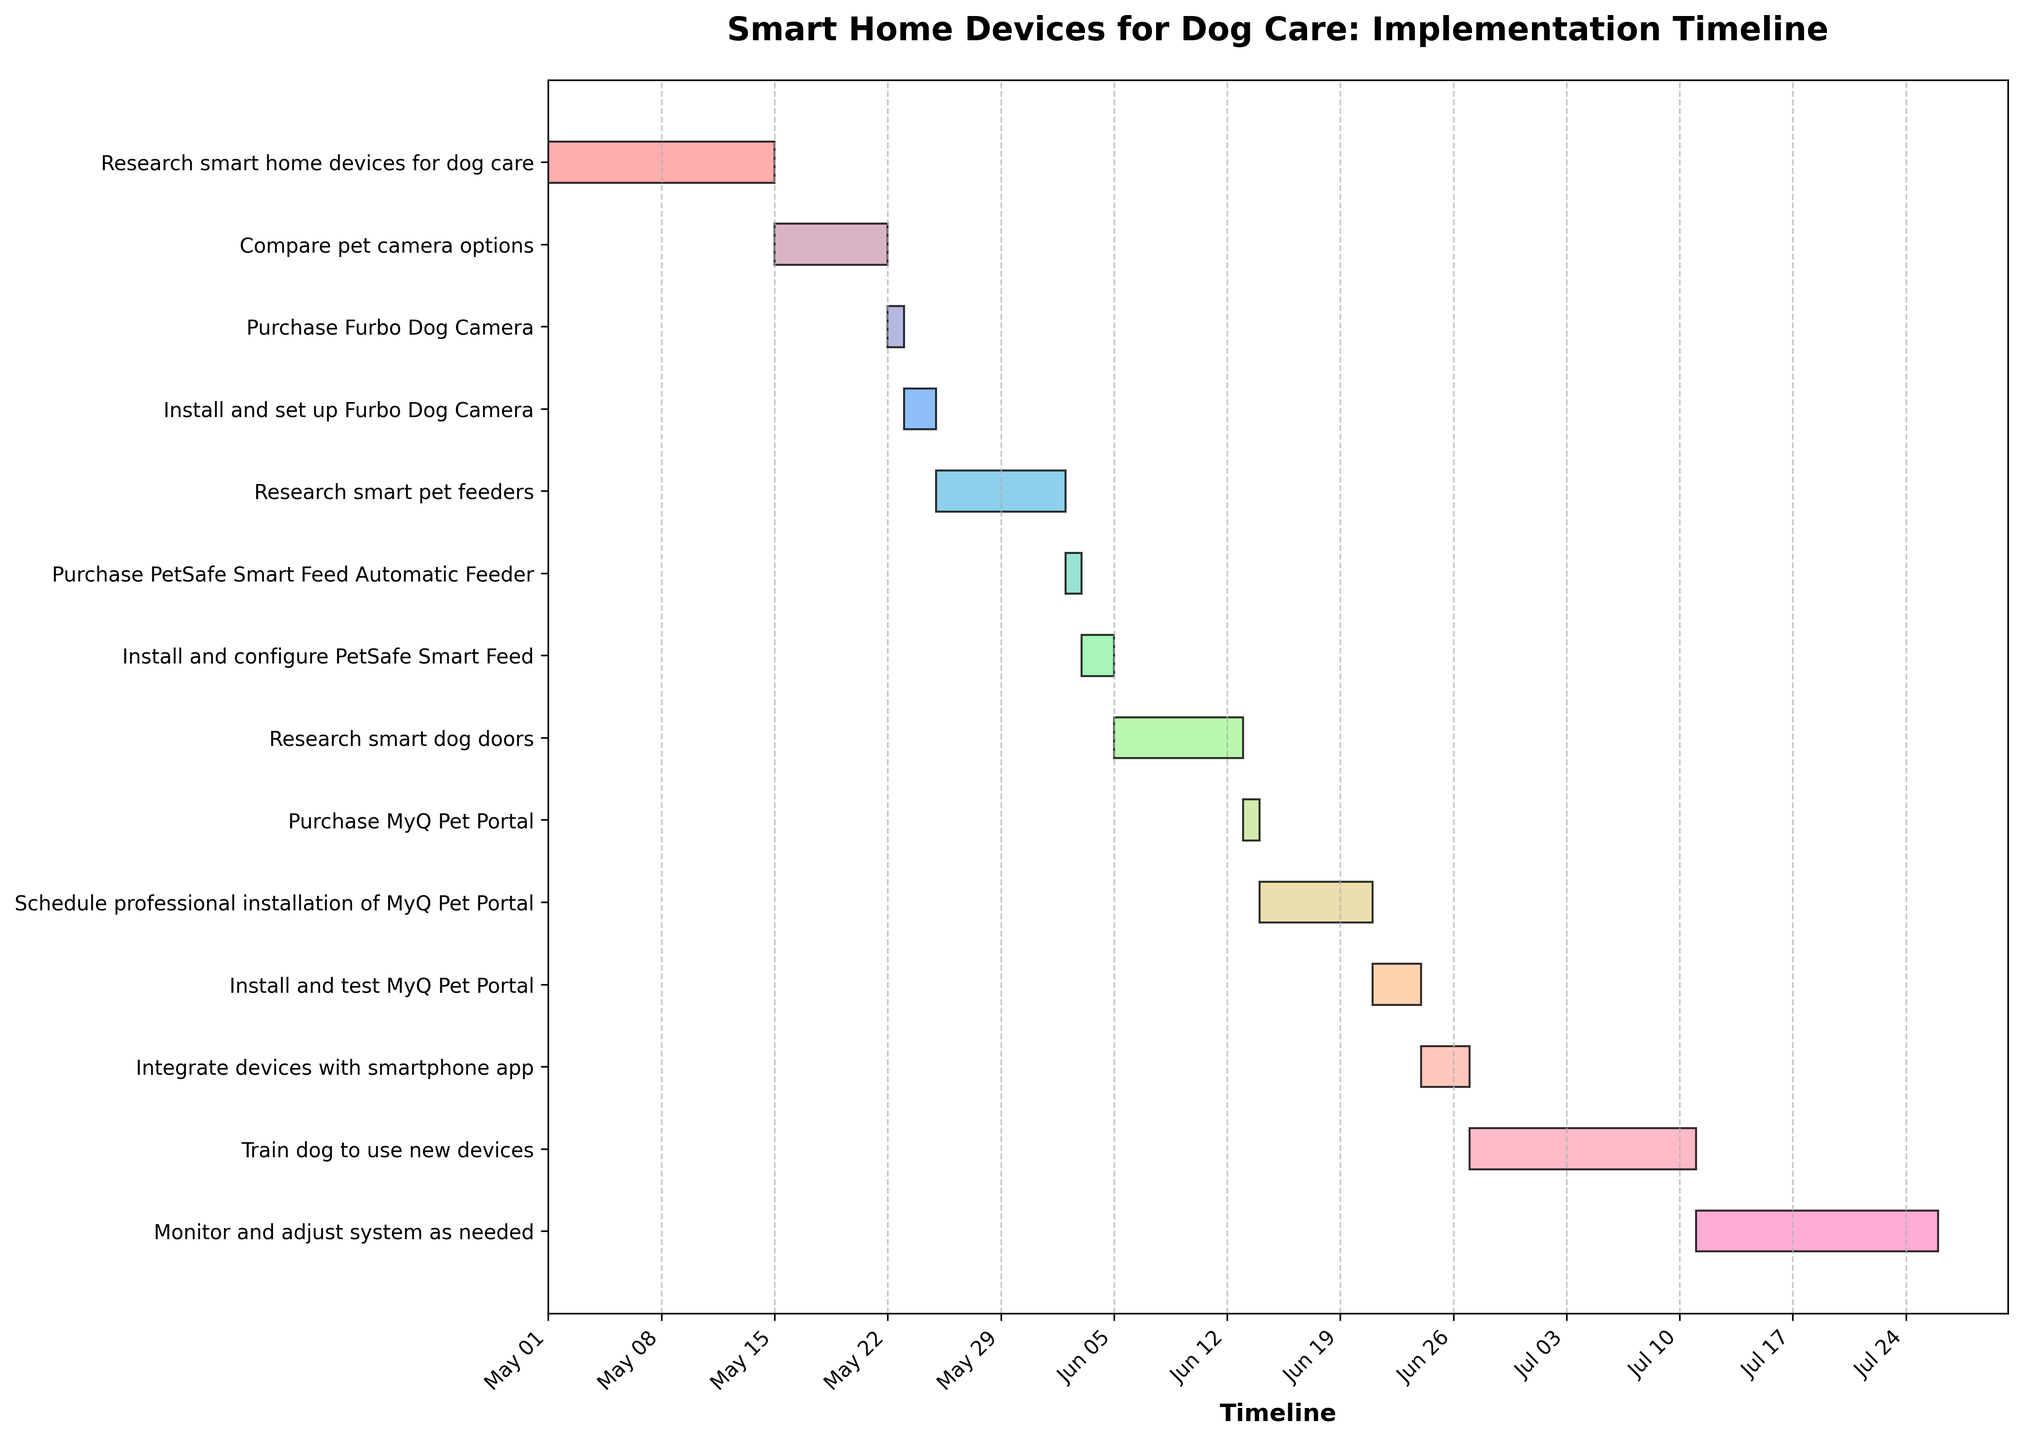What is the title of the Gantt chart? The title of a chart is typically located at the top and gives an overview of what the chart is about. Here, the title explicitly mentions the purpose of the timeline shown in the Gantt chart.
Answer: Smart Home Devices for Dog Care: Implementation Timeline How many tasks are there in total? By counting the number of distinct task bars displayed on the y-axis of the Gantt chart, we can determine the total number of tasks.
Answer: 14 What is the duration of the task "Research smart pet feeders"? To find the duration, subtract the start date from the end date and add one day (since the start day is inclusive). This can be verified by checking the visual length of the task bar.
Answer: 8 days Which task starts immediately after "Compare pet camera options"? By looking at the order of tasks and their start dates, the task that starts immediately after "Compare pet camera options" can be identified as the one following it sequentially on the timeline.
Answer: Purchase Furbo Dog Camera Which task has the longest duration? Identifying the task with the longest bar on the Gantt chart will give us the task with the longest duration. This can be done by visually examining or calculating the duration of each task.
Answer: Train dog to use new devices Is the installation of MyQ Pet Portal scheduled before or after the configuration of the PetSafe Smart Feed? By comparing the start dates of the two tasks, we can determine if the installation of MyQ Pet Portal occurs before or after the configuration of the PetSafe Smart Feed.
Answer: After What is the total duration from starting "Research smart home devices for dog care” to completing "Monitor and adjust system as needed”? By calculating the difference between the end date of the last task and the start date of the first task, we can find the total duration of the entire project timeline.
Answer: 86 days How many tasks involve purchasing a device? By identifying tasks with "purchase" in the description, we can count the number of such tasks.
Answer: 3 Which task has the shortest duration? The task with the shortest visual bar length on the Gantt chart will have the shortest duration, confirmed by further checking the start and end dates.
Answer: Purchase Furbo Dog Camera Compare the durations of "Install and set up Furbo Dog Camera" and "Install and configure PetSafe Smart Feed". Which one takes longer? By calculating the duration of both tasks and comparing the values, we can determine which one takes longer. Both can also be visually compared on the chart.
Answer: Install and set up Furbo Dog Camera takes longer 